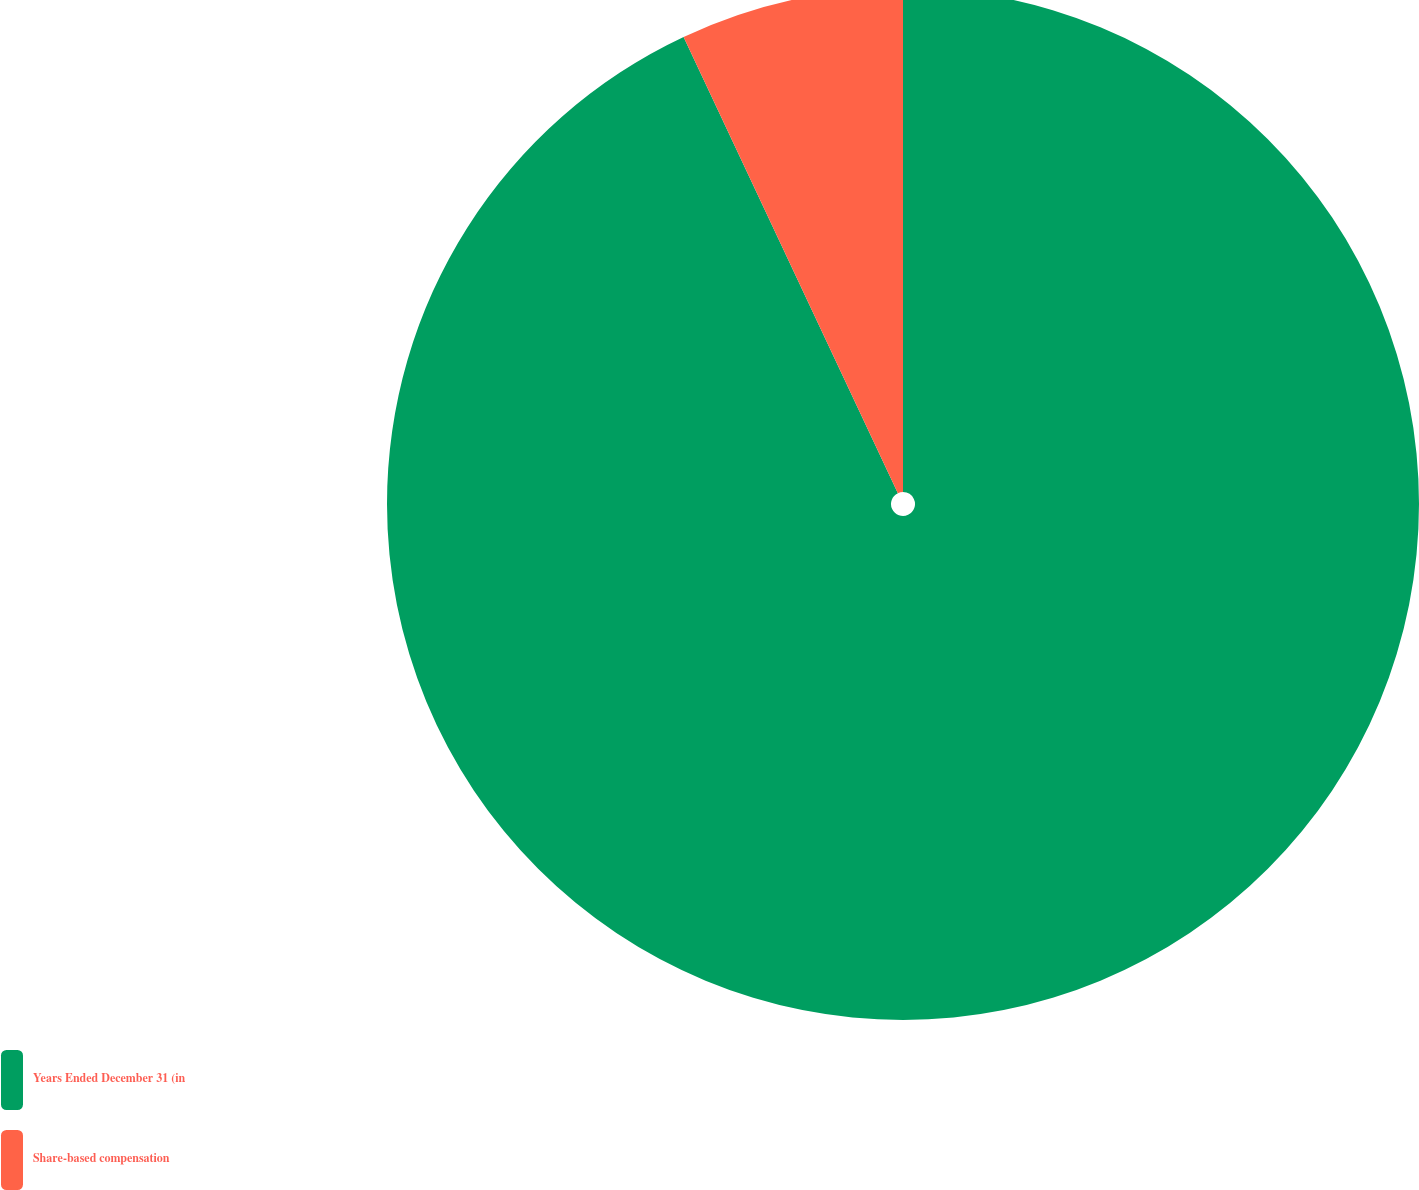Convert chart to OTSL. <chart><loc_0><loc_0><loc_500><loc_500><pie_chart><fcel>Years Ended December 31 (in<fcel>Share-based compensation<nl><fcel>93.01%<fcel>6.99%<nl></chart> 